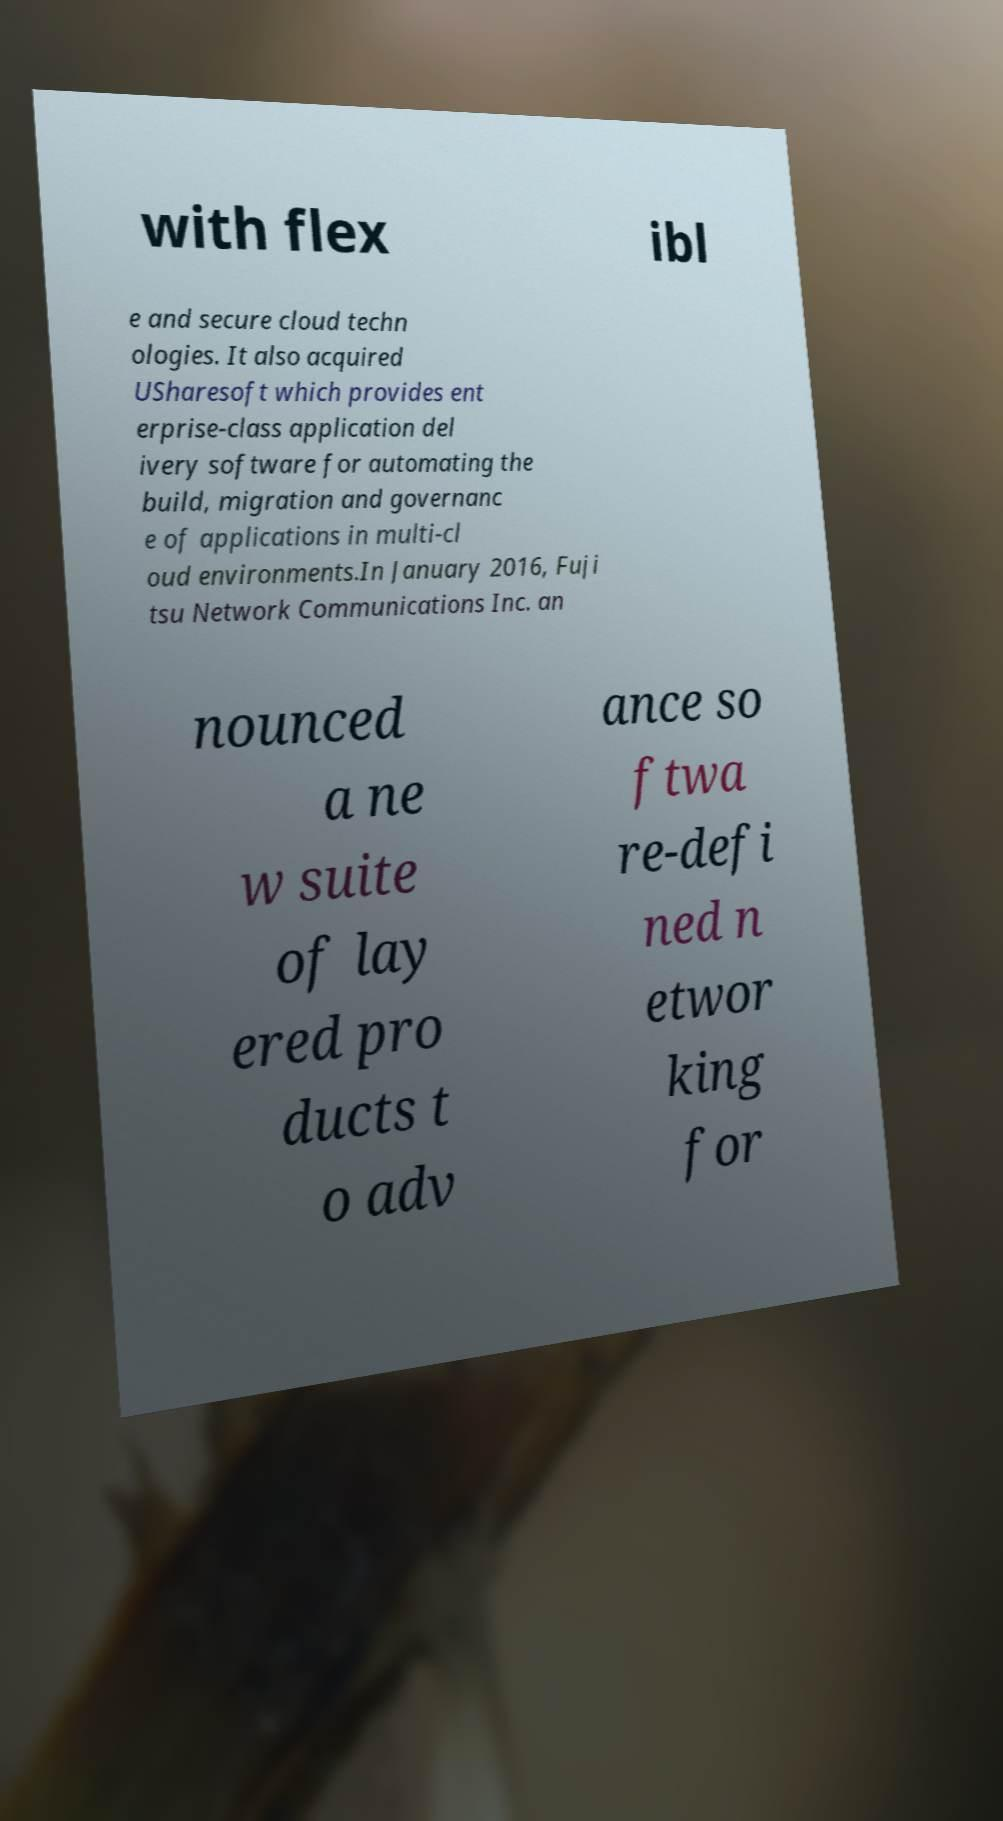Please read and relay the text visible in this image. What does it say? with flex ibl e and secure cloud techn ologies. It also acquired USharesoft which provides ent erprise-class application del ivery software for automating the build, migration and governanc e of applications in multi-cl oud environments.In January 2016, Fuji tsu Network Communications Inc. an nounced a ne w suite of lay ered pro ducts t o adv ance so ftwa re-defi ned n etwor king for 